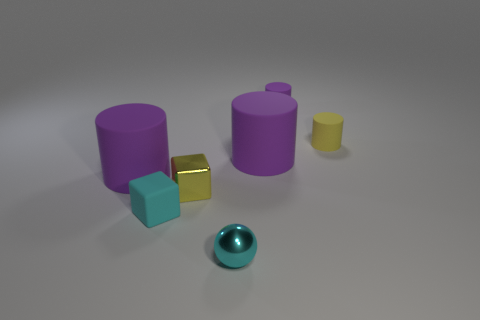How many purple cylinders must be subtracted to get 1 purple cylinders? 2 Subtract all brown spheres. How many purple cylinders are left? 3 Subtract 1 cylinders. How many cylinders are left? 3 Add 2 big red spheres. How many objects exist? 9 Subtract all cylinders. How many objects are left? 3 Add 6 yellow metallic blocks. How many yellow metallic blocks exist? 7 Subtract 0 gray balls. How many objects are left? 7 Subtract all cubes. Subtract all big brown shiny cylinders. How many objects are left? 5 Add 4 tiny objects. How many tiny objects are left? 9 